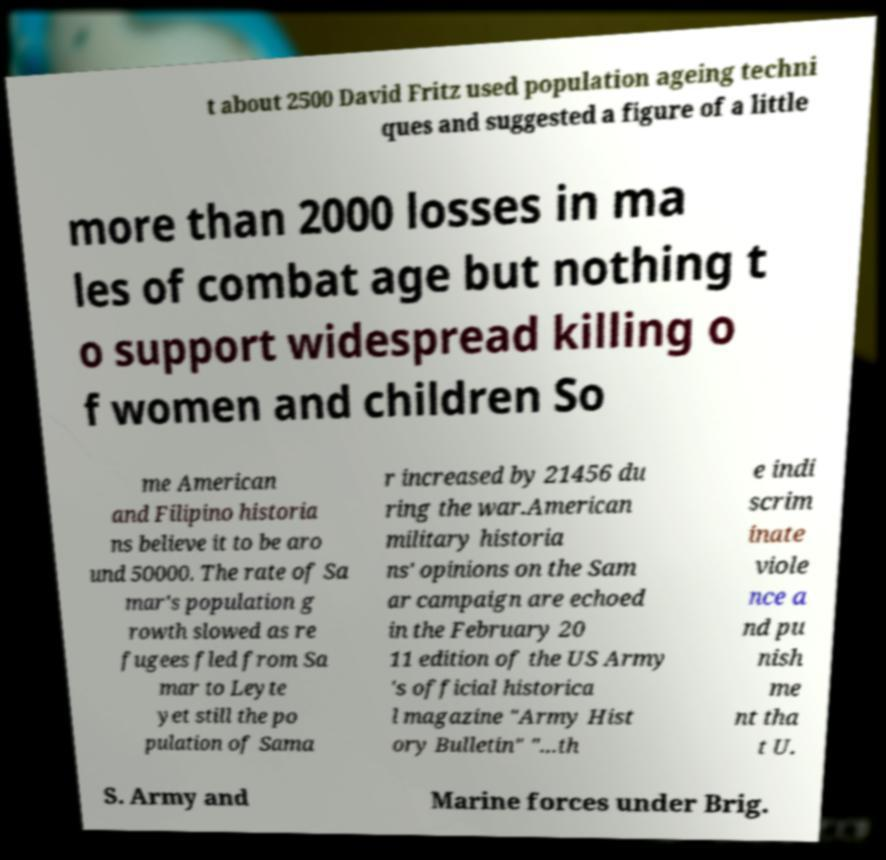There's text embedded in this image that I need extracted. Can you transcribe it verbatim? t about 2500 David Fritz used population ageing techni ques and suggested a figure of a little more than 2000 losses in ma les of combat age but nothing t o support widespread killing o f women and children So me American and Filipino historia ns believe it to be aro und 50000. The rate of Sa mar's population g rowth slowed as re fugees fled from Sa mar to Leyte yet still the po pulation of Sama r increased by 21456 du ring the war.American military historia ns' opinions on the Sam ar campaign are echoed in the February 20 11 edition of the US Army 's official historica l magazine "Army Hist ory Bulletin" "...th e indi scrim inate viole nce a nd pu nish me nt tha t U. S. Army and Marine forces under Brig. 